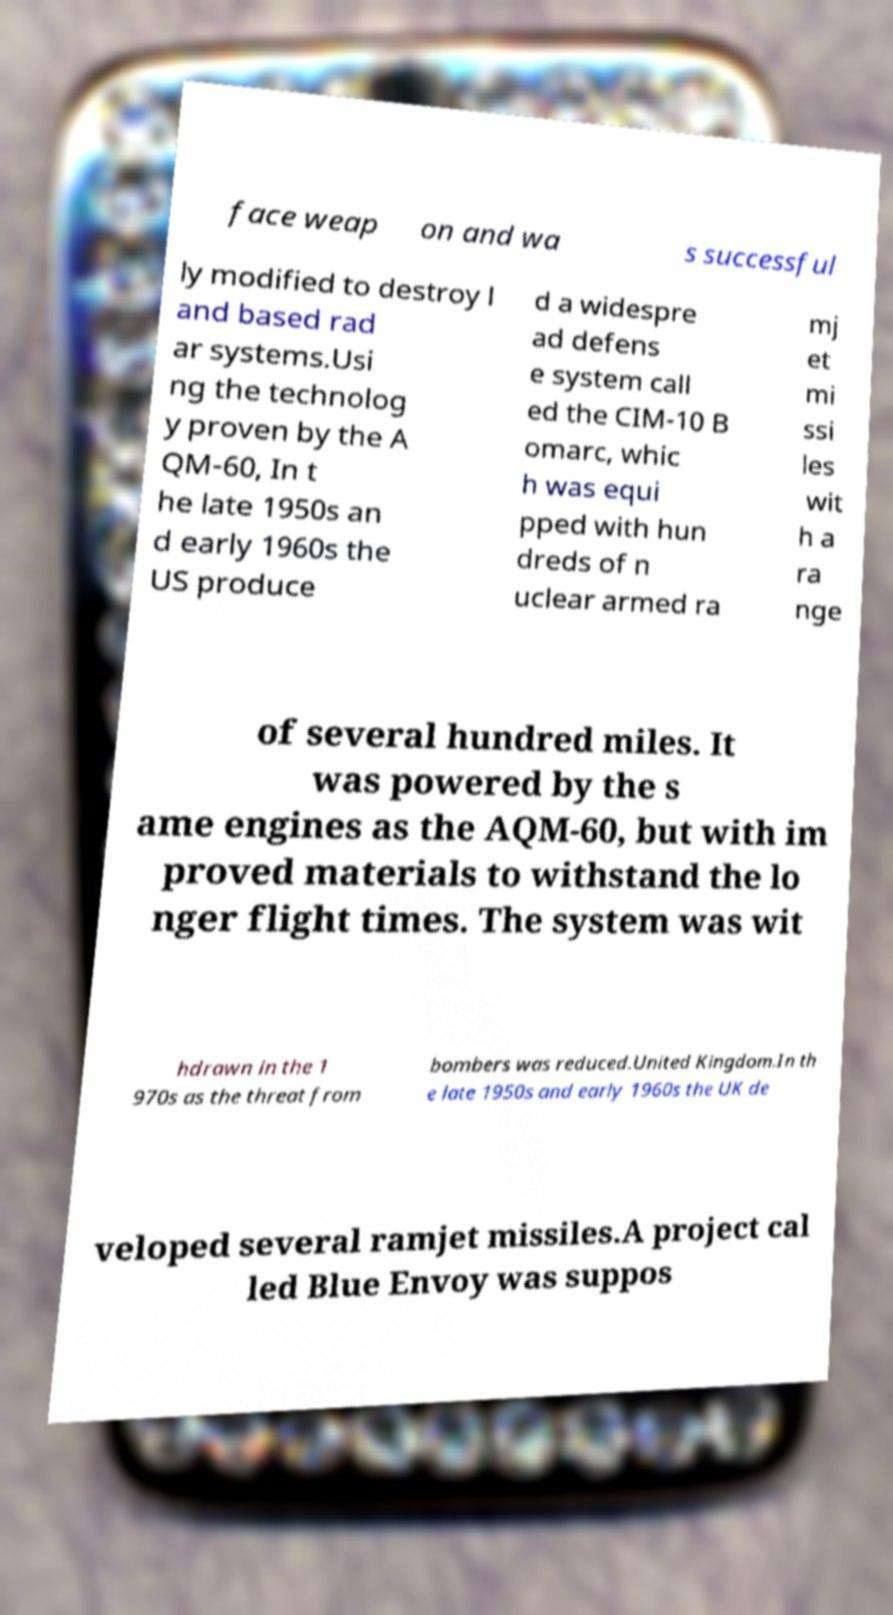What messages or text are displayed in this image? I need them in a readable, typed format. face weap on and wa s successful ly modified to destroy l and based rad ar systems.Usi ng the technolog y proven by the A QM-60, In t he late 1950s an d early 1960s the US produce d a widespre ad defens e system call ed the CIM-10 B omarc, whic h was equi pped with hun dreds of n uclear armed ra mj et mi ssi les wit h a ra nge of several hundred miles. It was powered by the s ame engines as the AQM-60, but with im proved materials to withstand the lo nger flight times. The system was wit hdrawn in the 1 970s as the threat from bombers was reduced.United Kingdom.In th e late 1950s and early 1960s the UK de veloped several ramjet missiles.A project cal led Blue Envoy was suppos 